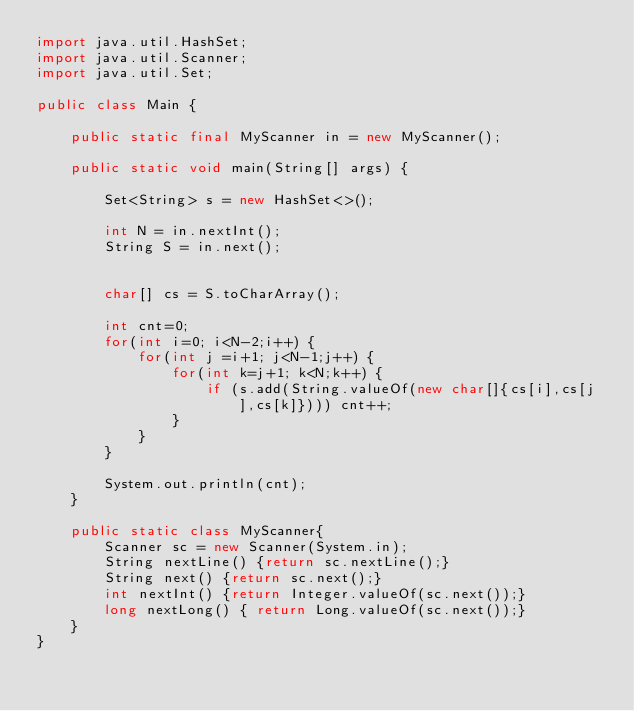Convert code to text. <code><loc_0><loc_0><loc_500><loc_500><_Java_>import java.util.HashSet;
import java.util.Scanner;
import java.util.Set;
 
public class Main {

	public static final MyScanner in = new MyScanner();

	public static void main(String[] args) {

		Set<String> s = new HashSet<>();

		int N = in.nextInt();
		String S = in.next();


		char[] cs = S.toCharArray();

		int cnt=0;
		for(int i=0; i<N-2;i++) {
			for(int j =i+1; j<N-1;j++) {
				for(int k=j+1; k<N;k++) {
					if (s.add(String.valueOf(new char[]{cs[i],cs[j],cs[k]}))) cnt++;
				}
			}
		}

		System.out.println(cnt);
	}

	public static class MyScanner{
		Scanner sc = new Scanner(System.in);
		String nextLine() {return sc.nextLine();}
		String next() {return sc.next();}
		int nextInt() {return Integer.valueOf(sc.next());}
		long nextLong() { return Long.valueOf(sc.next());}
	}
}</code> 